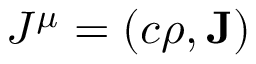Convert formula to latex. <formula><loc_0><loc_0><loc_500><loc_500>J ^ { \mu } = \left ( c \rho , { J } \right )</formula> 